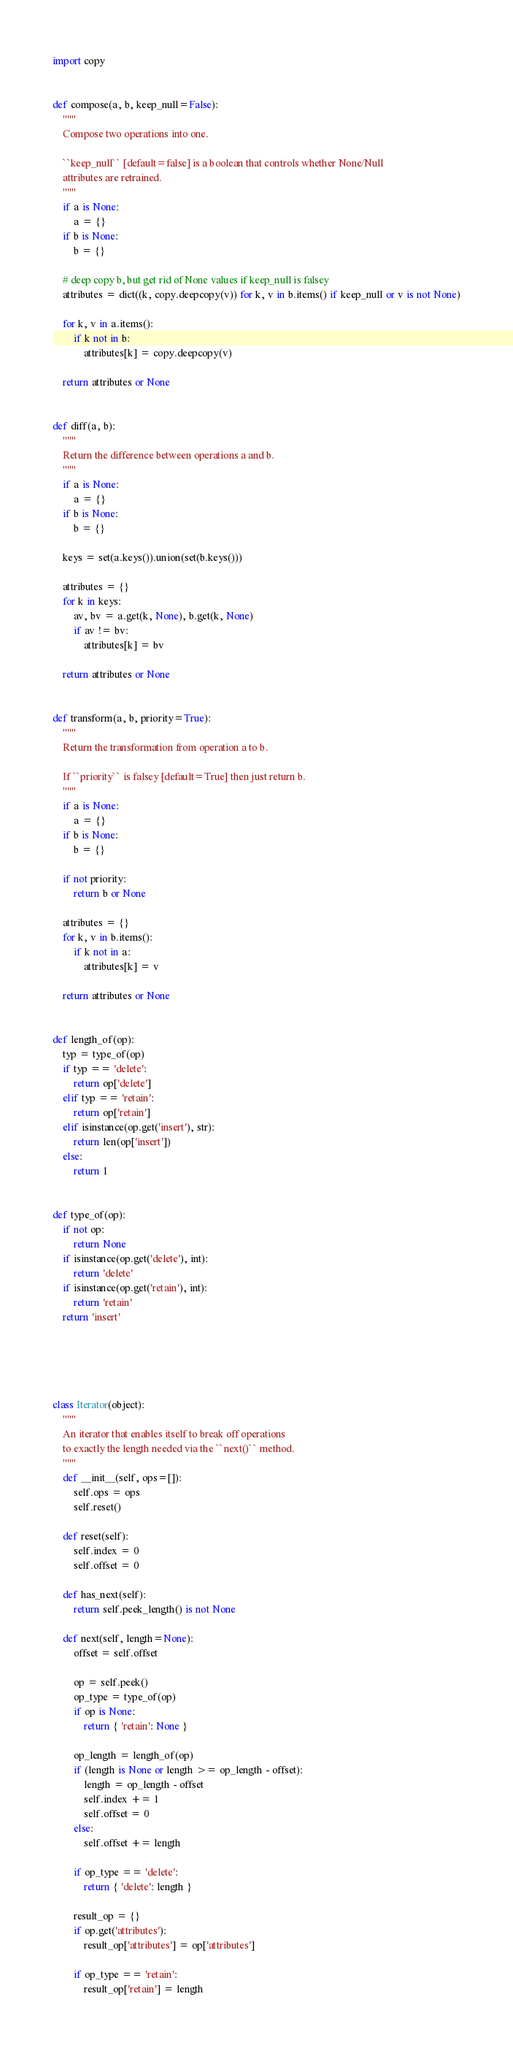Convert code to text. <code><loc_0><loc_0><loc_500><loc_500><_Python_>import copy


def compose(a, b, keep_null=False):
    """
    Compose two operations into one.

    ``keep_null`` [default=false] is a boolean that controls whether None/Null 
    attributes are retrained.
    """
    if a is None:
        a = {}
    if b is None:
        b = {}

    # deep copy b, but get rid of None values if keep_null is falsey
    attributes = dict((k, copy.deepcopy(v)) for k, v in b.items() if keep_null or v is not None)

    for k, v in a.items():
        if k not in b:
            attributes[k] = copy.deepcopy(v)

    return attributes or None


def diff(a, b):
    """
    Return the difference between operations a and b.
    """
    if a is None:
        a = {}
    if b is None:
        b = {}

    keys = set(a.keys()).union(set(b.keys()))

    attributes = {}
    for k in keys:
        av, bv = a.get(k, None), b.get(k, None)
        if av != bv:
            attributes[k] = bv

    return attributes or None


def transform(a, b, priority=True):
    """
    Return the transformation from operation a to b.

    If ``priority`` is falsey [default=True] then just return b.
    """
    if a is None:
        a = {}
    if b is None:
        b = {}

    if not priority:
        return b or None
    
    attributes = {}
    for k, v in b.items():
        if k not in a:
            attributes[k] = v

    return attributes or None


def length_of(op):
    typ = type_of(op)
    if typ == 'delete':
        return op['delete']
    elif typ == 'retain':
        return op['retain']
    elif isinstance(op.get('insert'), str):
        return len(op['insert'])
    else:
        return 1


def type_of(op):
    if not op:
        return None
    if isinstance(op.get('delete'), int):
        return 'delete'
    if isinstance(op.get('retain'), int):
        return 'retain'
    return 'insert'





class Iterator(object):
    """
    An iterator that enables itself to break off operations
    to exactly the length needed via the ``next()`` method.
    """
    def __init__(self, ops=[]):
        self.ops = ops
        self.reset()

    def reset(self):
        self.index = 0
        self.offset = 0

    def has_next(self):
        return self.peek_length() is not None

    def next(self, length=None):
        offset = self.offset

        op = self.peek()
        op_type = type_of(op)
        if op is None:
            return { 'retain': None }
        
        op_length = length_of(op)
        if (length is None or length >= op_length - offset):
            length = op_length - offset
            self.index += 1
            self.offset = 0
        else:
            self.offset += length

        if op_type == 'delete':
            return { 'delete': length }

        result_op = {}
        if op.get('attributes'):
            result_op['attributes'] = op['attributes']

        if op_type == 'retain':
            result_op['retain'] = length</code> 